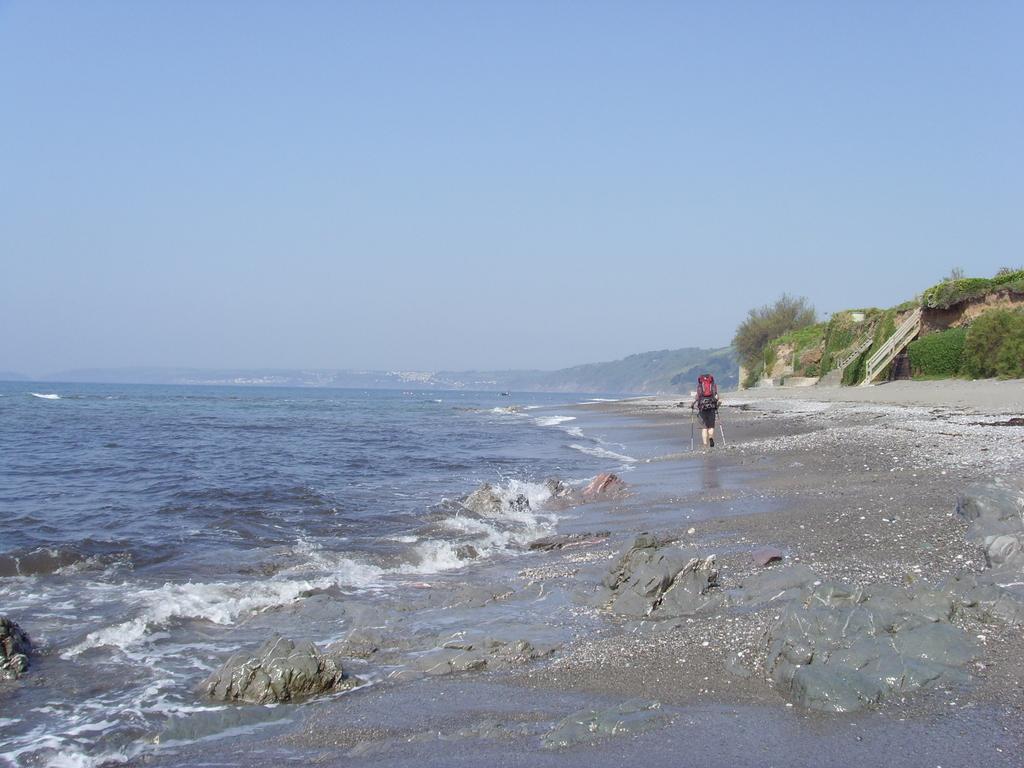Could you give a brief overview of what you see in this image? In this image I can see a person holding two sticks and walking. The person is wearing black color dress,background I can see the water, trees in green color and the sky is in blue color. 